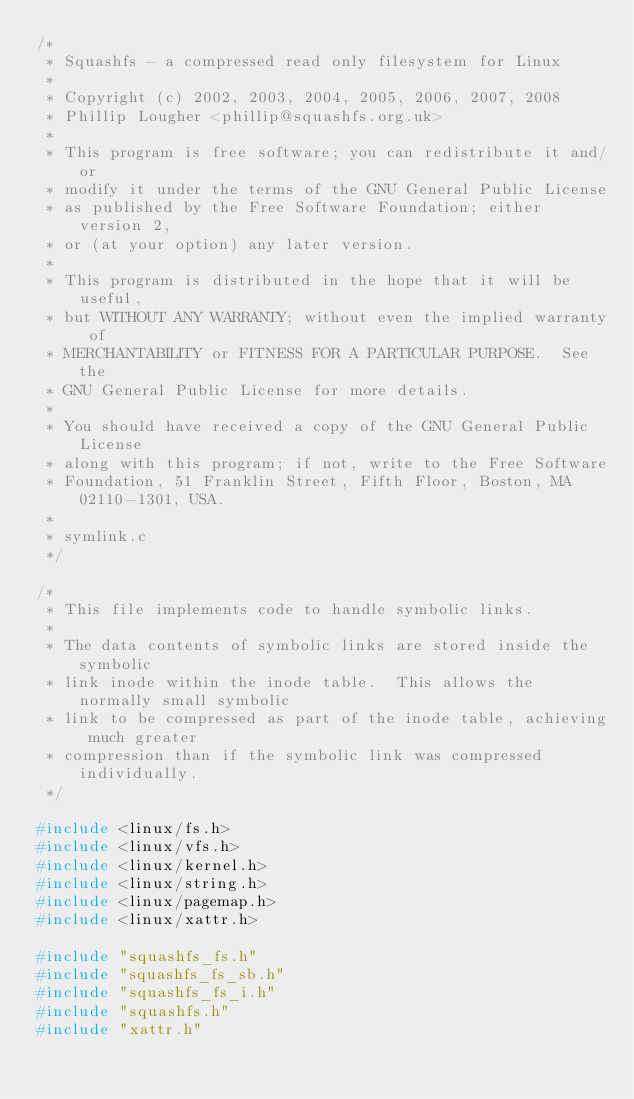Convert code to text. <code><loc_0><loc_0><loc_500><loc_500><_C_>/*
 * Squashfs - a compressed read only filesystem for Linux
 *
 * Copyright (c) 2002, 2003, 2004, 2005, 2006, 2007, 2008
 * Phillip Lougher <phillip@squashfs.org.uk>
 *
 * This program is free software; you can redistribute it and/or
 * modify it under the terms of the GNU General Public License
 * as published by the Free Software Foundation; either version 2,
 * or (at your option) any later version.
 *
 * This program is distributed in the hope that it will be useful,
 * but WITHOUT ANY WARRANTY; without even the implied warranty of
 * MERCHANTABILITY or FITNESS FOR A PARTICULAR PURPOSE.  See the
 * GNU General Public License for more details.
 *
 * You should have received a copy of the GNU General Public License
 * along with this program; if not, write to the Free Software
 * Foundation, 51 Franklin Street, Fifth Floor, Boston, MA 02110-1301, USA.
 *
 * symlink.c
 */

/*
 * This file implements code to handle symbolic links.
 *
 * The data contents of symbolic links are stored inside the symbolic
 * link inode within the inode table.  This allows the normally small symbolic
 * link to be compressed as part of the inode table, achieving much greater
 * compression than if the symbolic link was compressed individually.
 */

#include <linux/fs.h>
#include <linux/vfs.h>
#include <linux/kernel.h>
#include <linux/string.h>
#include <linux/pagemap.h>
#include <linux/xattr.h>

#include "squashfs_fs.h"
#include "squashfs_fs_sb.h"
#include "squashfs_fs_i.h"
#include "squashfs.h"
#include "xattr.h"
</code> 